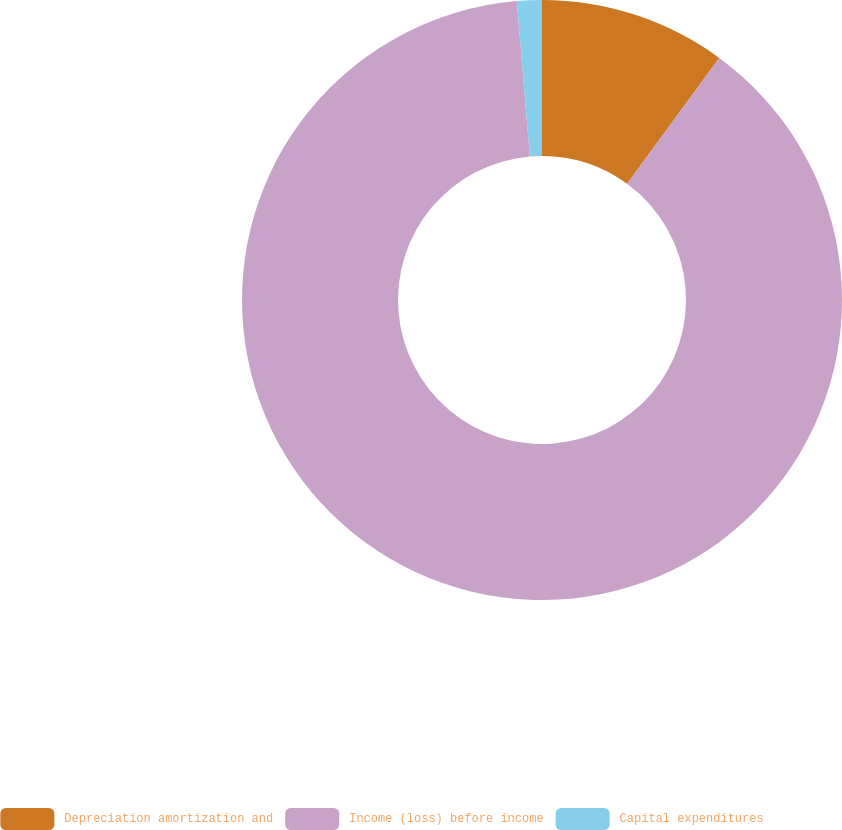<chart> <loc_0><loc_0><loc_500><loc_500><pie_chart><fcel>Depreciation amortization and<fcel>Income (loss) before income<fcel>Capital expenditures<nl><fcel>10.06%<fcel>88.6%<fcel>1.34%<nl></chart> 